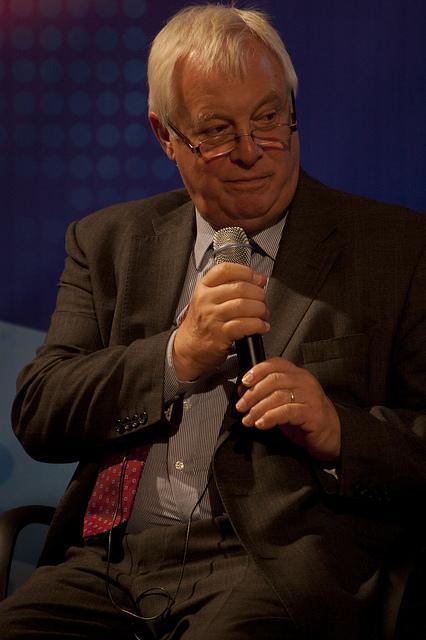What is he about to do?
Indicate the correct response by choosing from the four available options to answer the question.
Options: Speak, punish people, find food, eat dinner. Speak. 